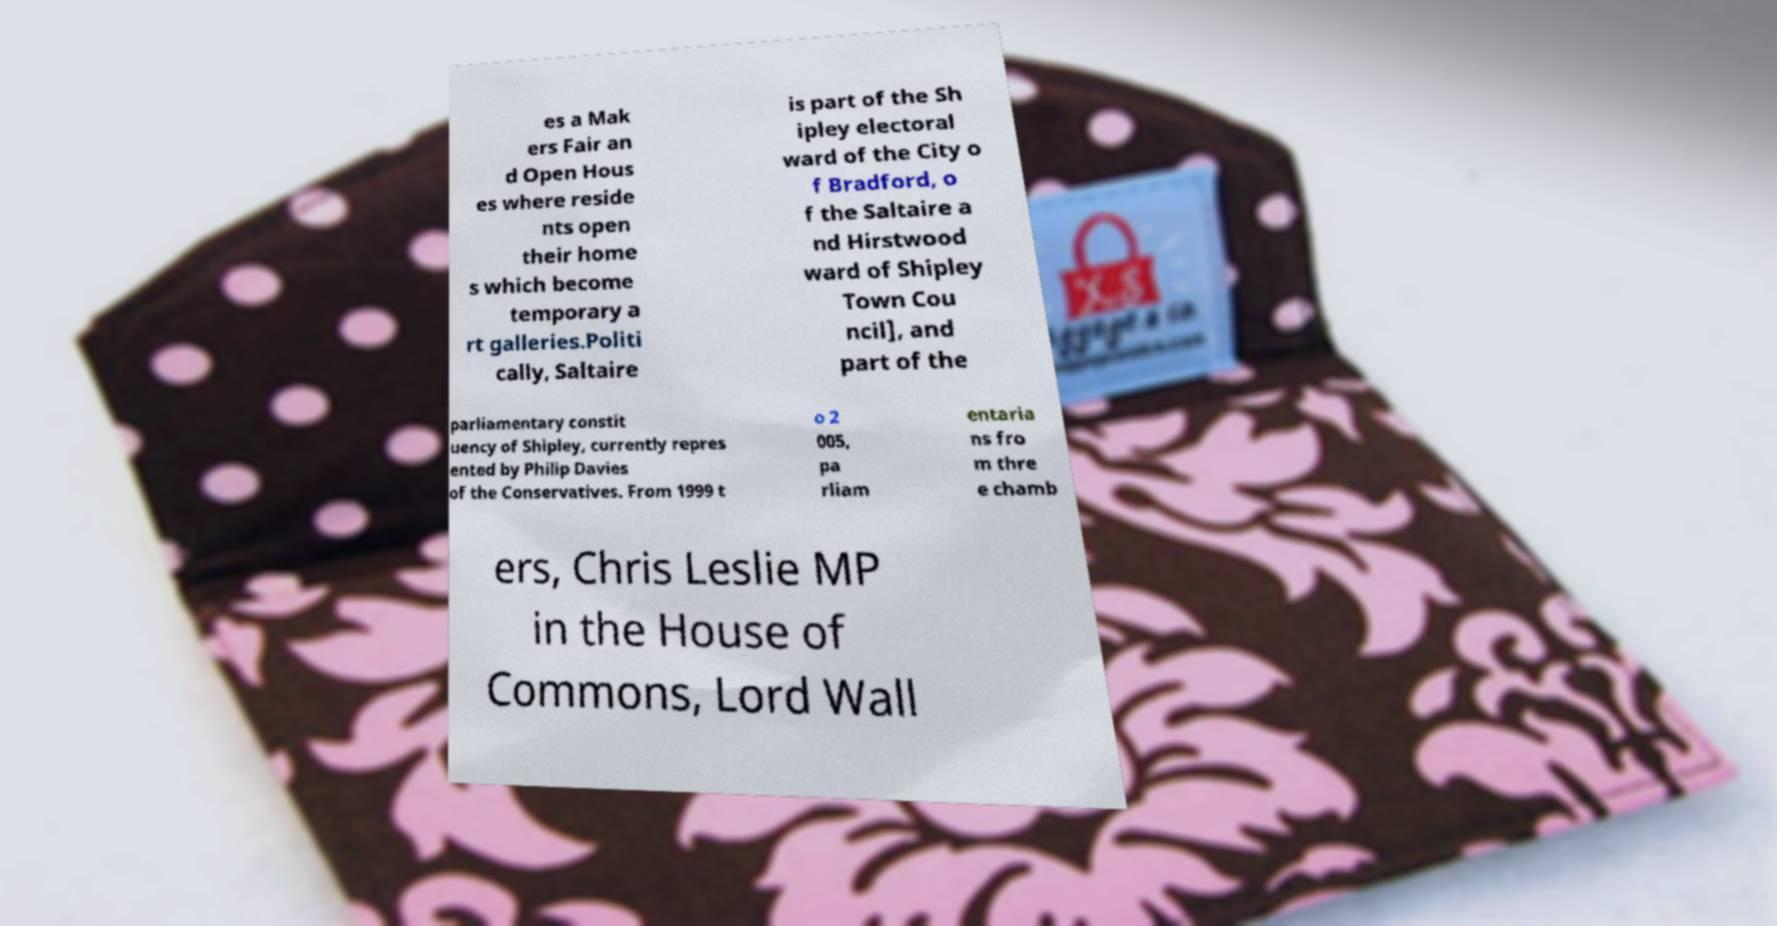Can you read and provide the text displayed in the image?This photo seems to have some interesting text. Can you extract and type it out for me? es a Mak ers Fair an d Open Hous es where reside nts open their home s which become temporary a rt galleries.Politi cally, Saltaire is part of the Sh ipley electoral ward of the City o f Bradford, o f the Saltaire a nd Hirstwood ward of Shipley Town Cou ncil], and part of the parliamentary constit uency of Shipley, currently repres ented by Philip Davies of the Conservatives. From 1999 t o 2 005, pa rliam entaria ns fro m thre e chamb ers, Chris Leslie MP in the House of Commons, Lord Wall 